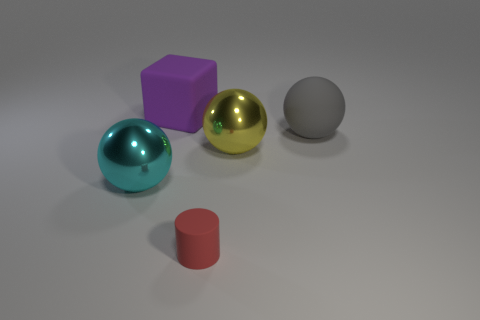What is the color of the object that is both behind the small cylinder and in front of the yellow metallic thing? The object in question is the middle-sized sphere with a cyan hue. It's situated directly behind the small red cylinder and in front of the shiny yellow sphere, giving it a distinct visual prominence due to its unique color and reflective material. 